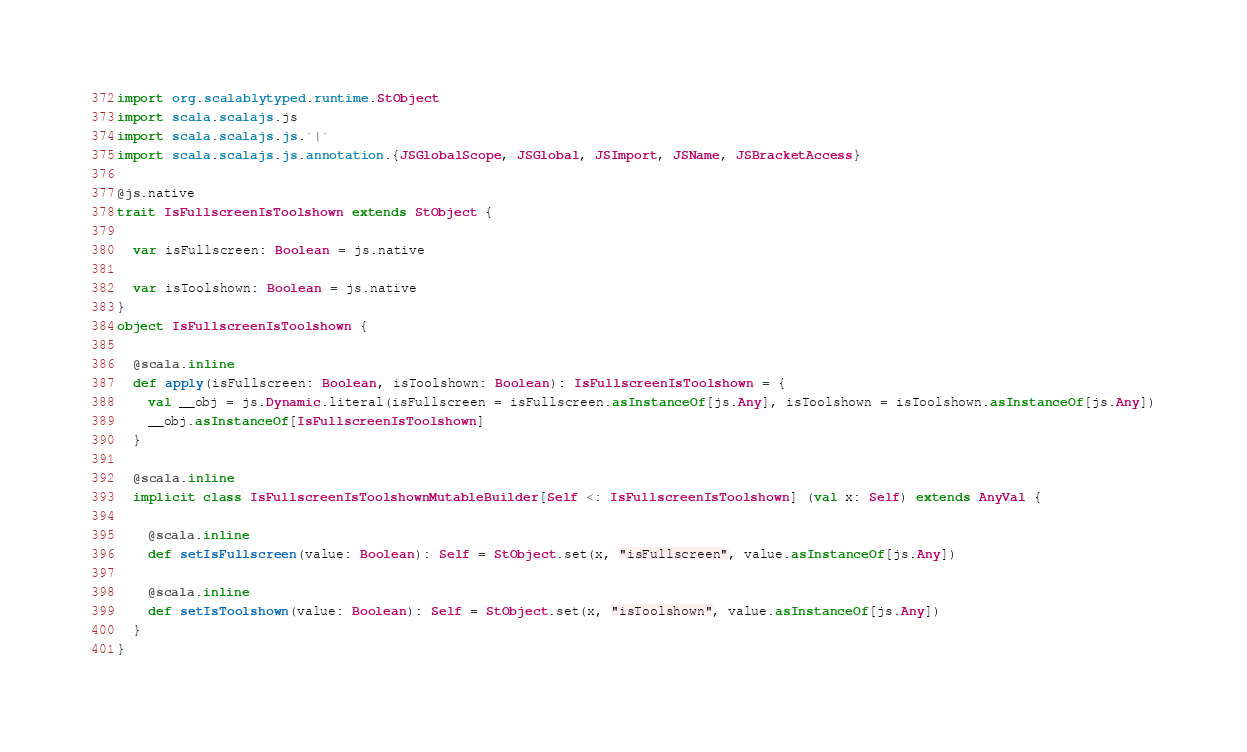Convert code to text. <code><loc_0><loc_0><loc_500><loc_500><_Scala_>import org.scalablytyped.runtime.StObject
import scala.scalajs.js
import scala.scalajs.js.`|`
import scala.scalajs.js.annotation.{JSGlobalScope, JSGlobal, JSImport, JSName, JSBracketAccess}

@js.native
trait IsFullscreenIsToolshown extends StObject {
  
  var isFullscreen: Boolean = js.native
  
  var isToolshown: Boolean = js.native
}
object IsFullscreenIsToolshown {
  
  @scala.inline
  def apply(isFullscreen: Boolean, isToolshown: Boolean): IsFullscreenIsToolshown = {
    val __obj = js.Dynamic.literal(isFullscreen = isFullscreen.asInstanceOf[js.Any], isToolshown = isToolshown.asInstanceOf[js.Any])
    __obj.asInstanceOf[IsFullscreenIsToolshown]
  }
  
  @scala.inline
  implicit class IsFullscreenIsToolshownMutableBuilder[Self <: IsFullscreenIsToolshown] (val x: Self) extends AnyVal {
    
    @scala.inline
    def setIsFullscreen(value: Boolean): Self = StObject.set(x, "isFullscreen", value.asInstanceOf[js.Any])
    
    @scala.inline
    def setIsToolshown(value: Boolean): Self = StObject.set(x, "isToolshown", value.asInstanceOf[js.Any])
  }
}
</code> 